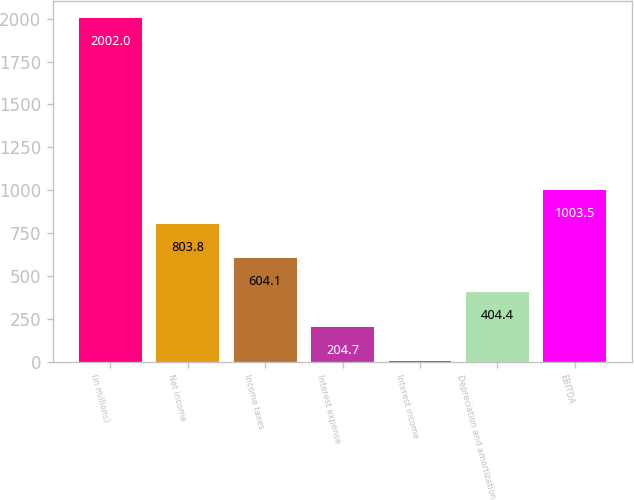<chart> <loc_0><loc_0><loc_500><loc_500><bar_chart><fcel>(in millions)<fcel>Net income<fcel>Income taxes<fcel>Interest expense<fcel>Interest income<fcel>Depreciation and amortization<fcel>EBITDA<nl><fcel>2002<fcel>803.8<fcel>604.1<fcel>204.7<fcel>5<fcel>404.4<fcel>1003.5<nl></chart> 